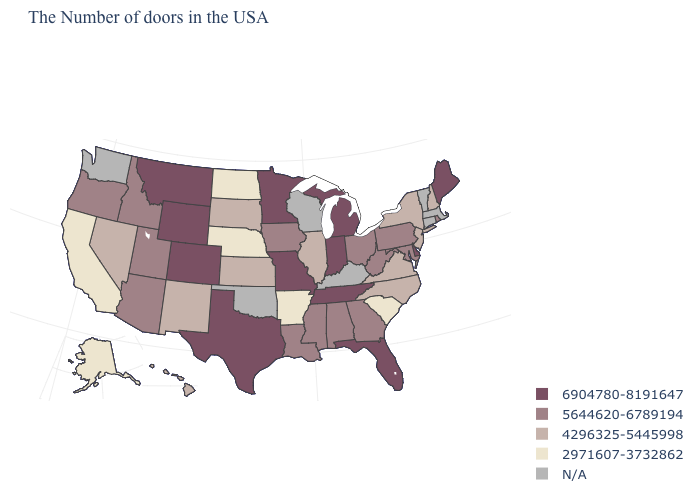What is the highest value in the Northeast ?
Quick response, please. 6904780-8191647. Is the legend a continuous bar?
Give a very brief answer. No. What is the value of Delaware?
Give a very brief answer. 6904780-8191647. Name the states that have a value in the range 5644620-6789194?
Be succinct. Rhode Island, Maryland, Pennsylvania, West Virginia, Ohio, Georgia, Alabama, Mississippi, Louisiana, Iowa, Utah, Arizona, Idaho, Oregon. Does the map have missing data?
Quick response, please. Yes. What is the value of Louisiana?
Write a very short answer. 5644620-6789194. What is the value of Utah?
Answer briefly. 5644620-6789194. What is the value of Montana?
Short answer required. 6904780-8191647. What is the value of Louisiana?
Answer briefly. 5644620-6789194. Which states have the lowest value in the USA?
Answer briefly. South Carolina, Arkansas, Nebraska, North Dakota, California, Alaska. What is the value of Kansas?
Short answer required. 4296325-5445998. What is the value of Oregon?
Concise answer only. 5644620-6789194. What is the value of Michigan?
Keep it brief. 6904780-8191647. 